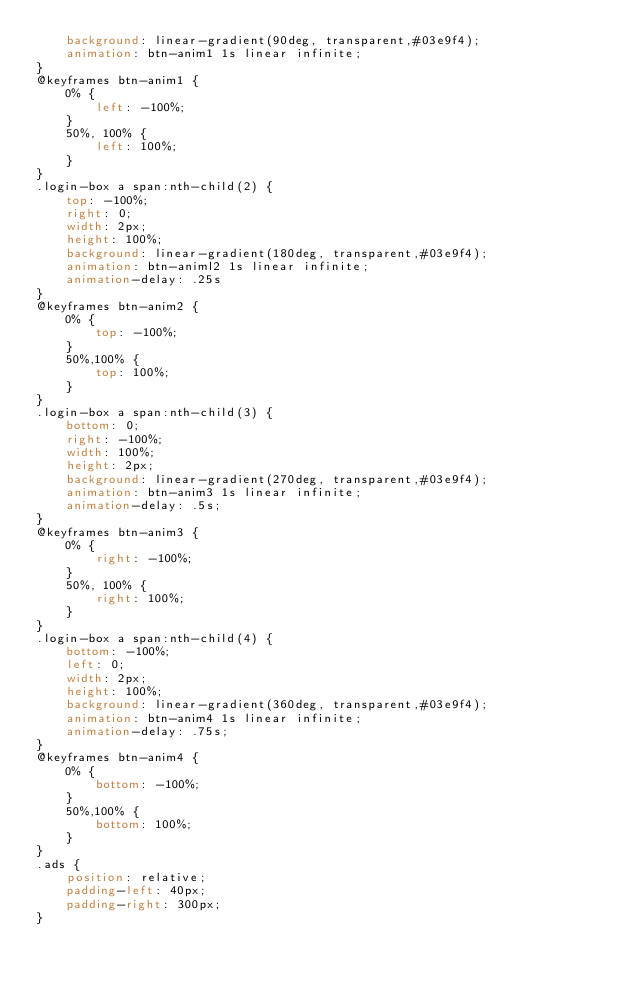<code> <loc_0><loc_0><loc_500><loc_500><_CSS_>    background: linear-gradient(90deg, transparent,#03e9f4);
    animation: btn-anim1 1s linear infinite;
}
@keyframes btn-anim1 {
    0% {
        left: -100%;
    }
    50%, 100% {
        left: 100%;
    }
}
.login-box a span:nth-child(2) {
    top: -100%;
    right: 0;
    width: 2px;
    height: 100%;
    background: linear-gradient(180deg, transparent,#03e9f4);
    animation: btn-animl2 1s linear infinite;
    animation-delay: .25s
}
@keyframes btn-anim2 {
    0% {
        top: -100%;
    }
    50%,100% {
        top: 100%;
    }
}
.login-box a span:nth-child(3) {
    bottom: 0;
    right: -100%;
    width: 100%;
    height: 2px;
    background: linear-gradient(270deg, transparent,#03e9f4);
    animation: btn-anim3 1s linear infinite;
    animation-delay: .5s;
}
@keyframes btn-anim3 {
    0% {
        right: -100%;
    }
    50%, 100% {
        right: 100%;
    }
}
.login-box a span:nth-child(4) {
    bottom: -100%;
    left: 0;
    width: 2px;
    height: 100%;
    background: linear-gradient(360deg, transparent,#03e9f4);
    animation: btn-anim4 1s linear infinite;
    animation-delay: .75s;
}
@keyframes btn-anim4 {
    0% {
        bottom: -100%;
    }
    50%,100% {
        bottom: 100%;
    }
}
.ads {
    position: relative;
    padding-left: 40px;
    padding-right: 300px;
}
</code> 